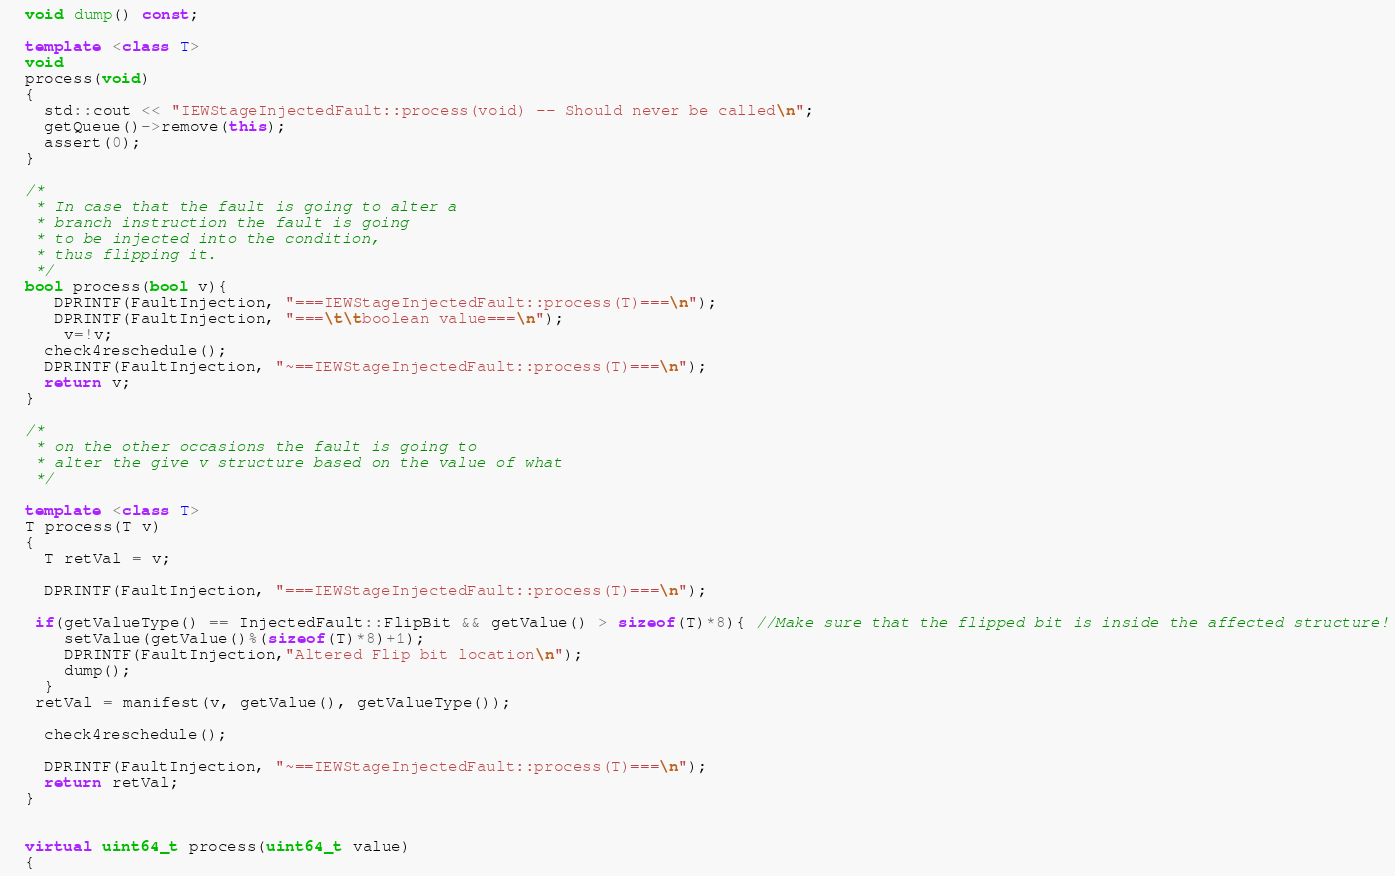Convert code to text. <code><loc_0><loc_0><loc_500><loc_500><_C++_>  void dump() const;

  template <class T>
  void
  process(void)
  { 
    std::cout << "IEWStageInjectedFault::process(void) -- Should never be called\n";
    getQueue()->remove(this);  
    assert(0);
  }
  
  /*
   * In case that the fault is going to alter a
   * branch instruction the fault is going 
   * to be injected into the condition,
   * thus flipping it.
   */
  bool process(bool v){
     DPRINTF(FaultInjection, "===IEWStageInjectedFault::process(T)===\n");
     DPRINTF(FaultInjection, "===\t\tboolean value===\n");
      v=!v;
    check4reschedule();
    DPRINTF(FaultInjection, "~==IEWStageInjectedFault::process(T)===\n");
    return v;
  }
  
  /*
   * on the other occasions the fault is going to 
   * alter the give v structure based on the value of what
   */
  
  template <class T>
  T process(T v)
  { 
    T retVal = v;
    
    DPRINTF(FaultInjection, "===IEWStageInjectedFault::process(T)===\n");
    
   if(getValueType() == InjectedFault::FlipBit && getValue() > sizeof(T)*8){ //Make sure that the flipped bit is inside the affected structure!
      setValue(getValue()%(sizeof(T)*8)+1);
      DPRINTF(FaultInjection,"Altered Flip bit location\n");
      dump();
    }
   retVal = manifest(v, getValue(), getValueType());
    
    check4reschedule();
    
    DPRINTF(FaultInjection, "~==IEWStageInjectedFault::process(T)===\n");
    return retVal;
  }


  virtual uint64_t process(uint64_t value)
  { </code> 